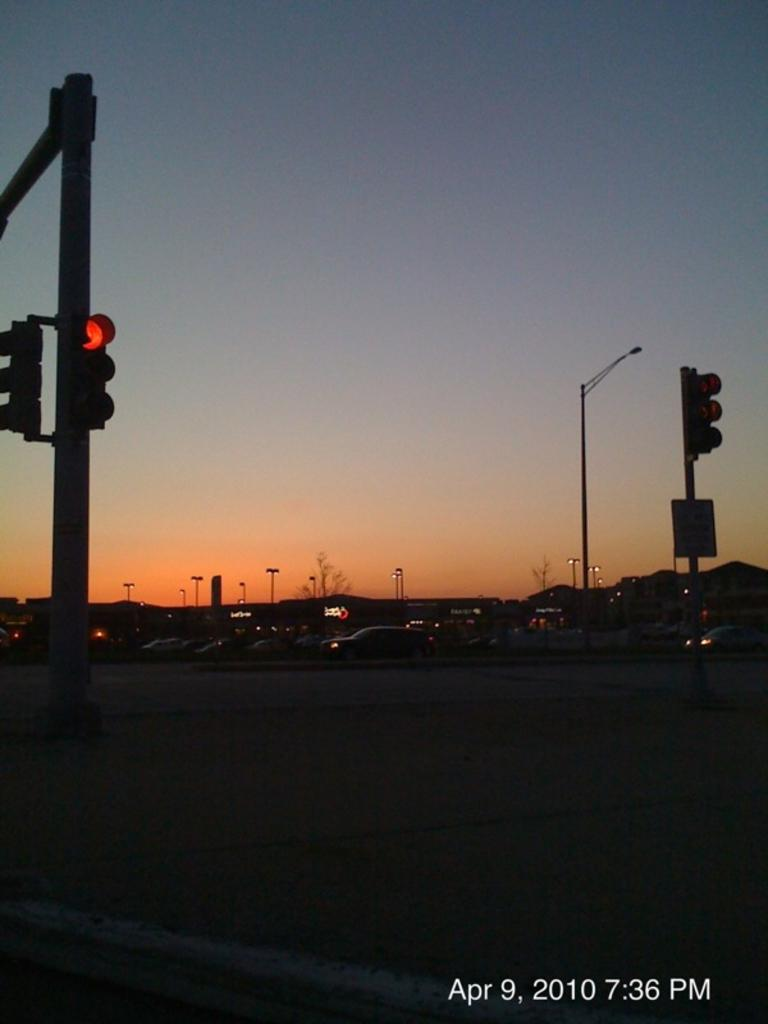What can be seen in the image that helps regulate traffic? There are traffic signals in the image. What type of objects can be seen in the background of the image? There are vehicles and poles in the background of the image. What can be seen in the sky in the image? The sky is visible in the image, with blue, white, and orange colors. Where is the airport located in the image? There is no airport present in the image. What type of fowl can be seen flying in the sky in the image? There are no fowl visible in the sky in the image. 